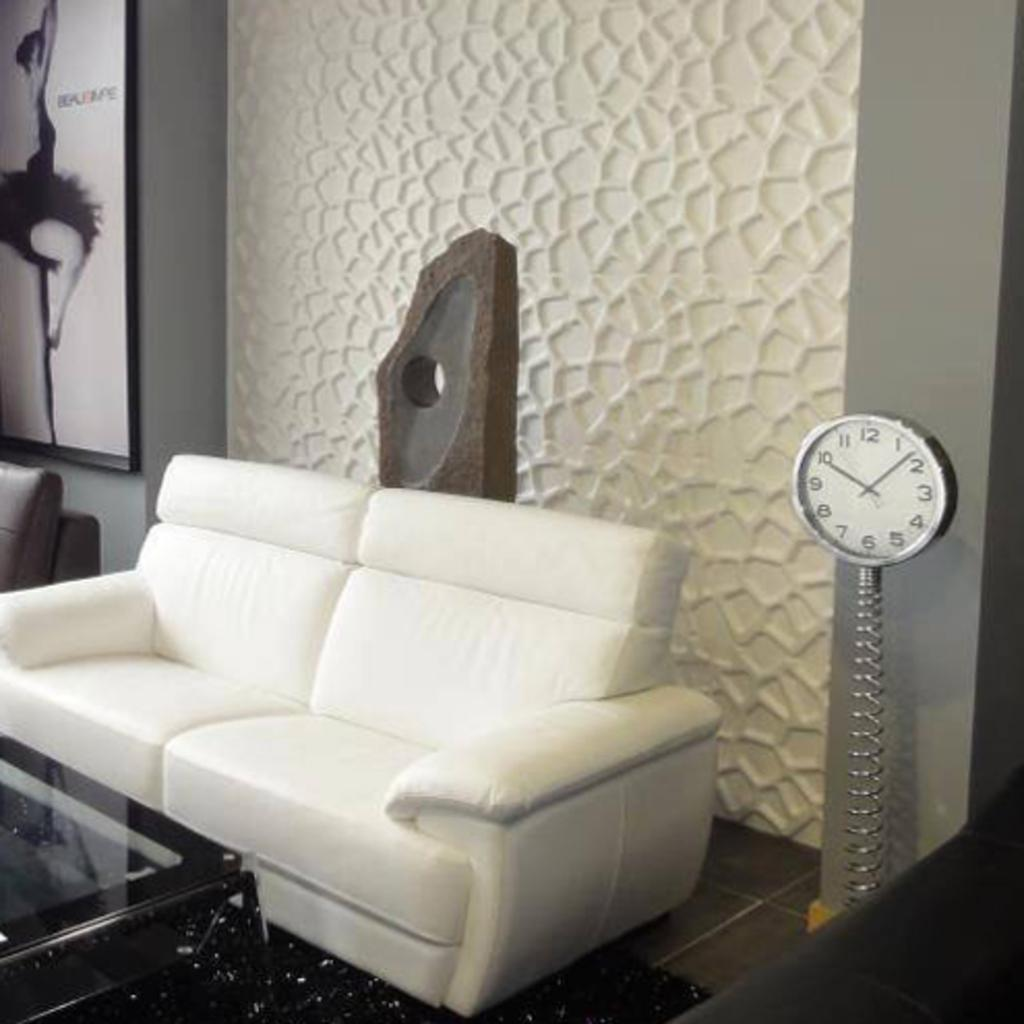<image>
Summarize the visual content of the image. White sofa next to a clock which has the hands on the numbers 10 and 2. 